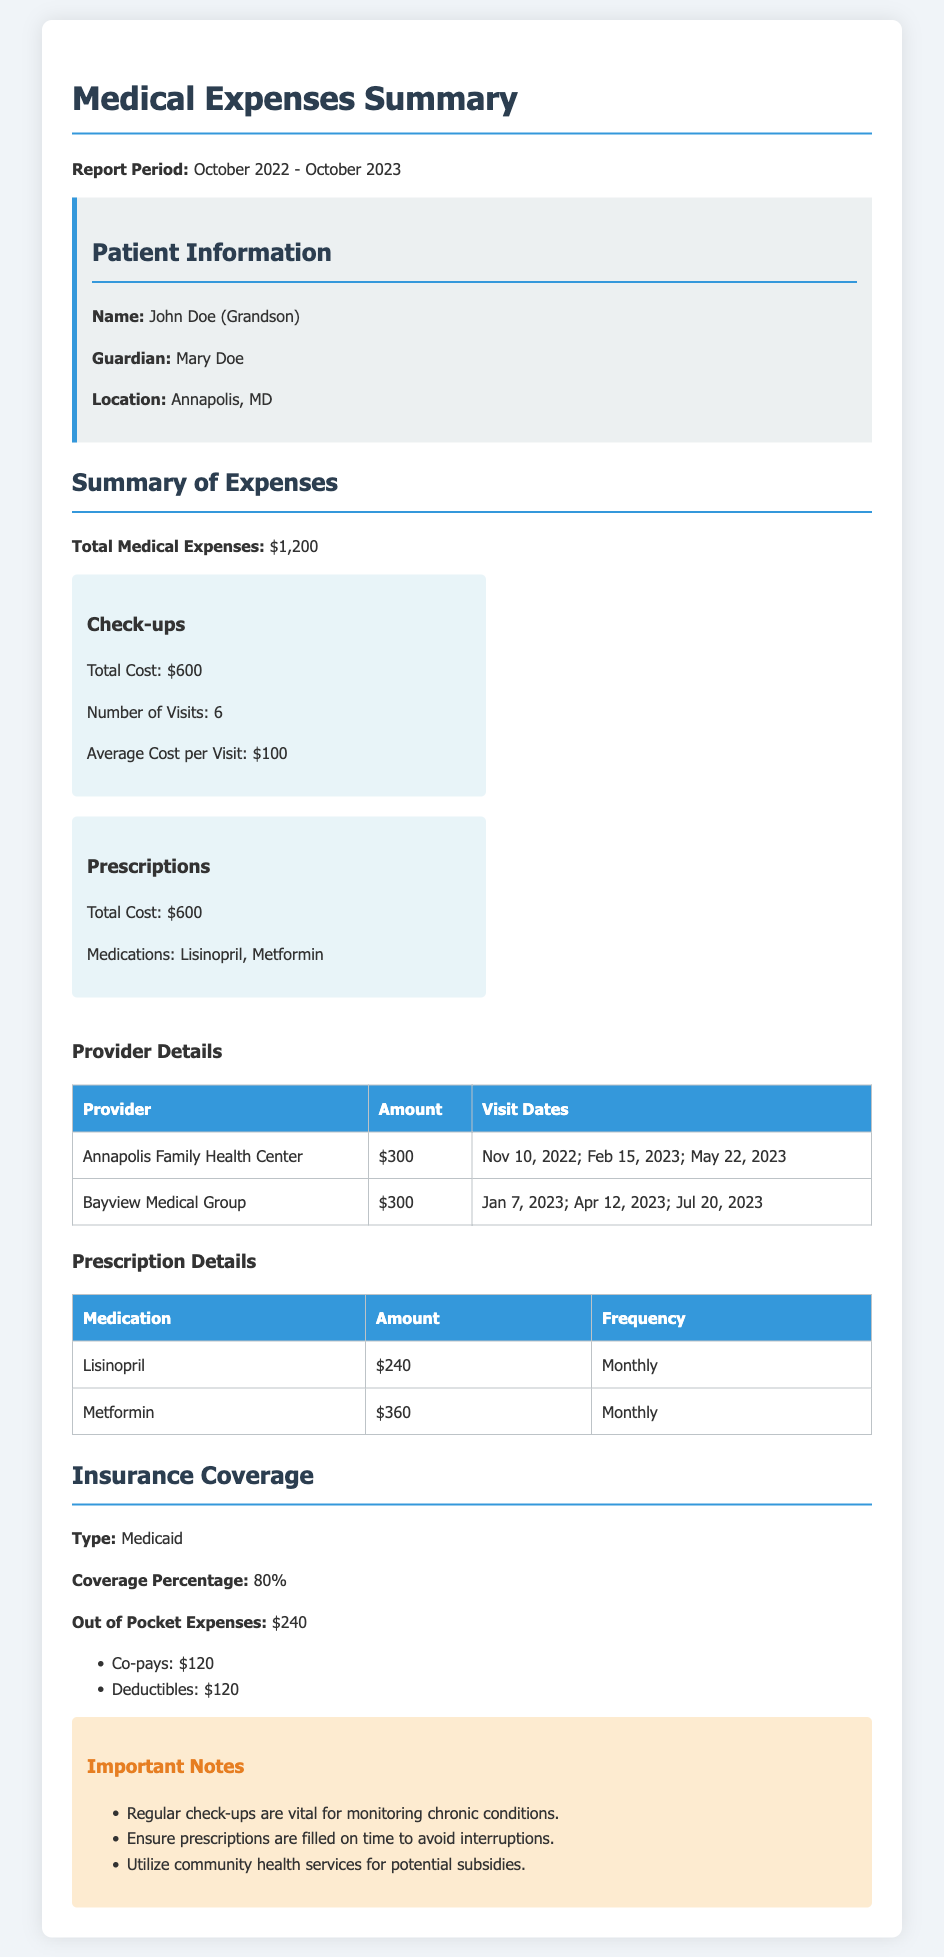What is the total cost of check-ups? The total cost of check-ups is clearly mentioned in the summary of expenses section.
Answer: $600 How many prescription medications are listed? The prescription details section shows the number of unique medications listed.
Answer: 2 What are the visit dates for Annapolis Family Health Center? The visit dates for this provider are provided in the provider details table.
Answer: Nov 10, 2022; Feb 15, 2023; May 22, 2023 What is the total medical expense amount? The total medical expenses amount is stated at the beginning of the summary of expenses section.
Answer: $1,200 What is the percentage of insurance coverage? The document specifies the coverage percentage under the insurance coverage section.
Answer: 80% How much is paid out of pocket for medical expenses? The out of pocket expenses figure is mentioned directly under the insurance coverage section.
Answer: $240 What is the average cost per check-up visit? The average cost per visit is calculated and stated in the breakdown for check-ups.
Answer: $100 How many visits were made over the year for check-ups? The number of visits for check-ups is provided in the expense breakdown section.
Answer: 6 What is the total cost of Metformin? The total cost for Metformin is listed in the prescription details table.
Answer: $360 